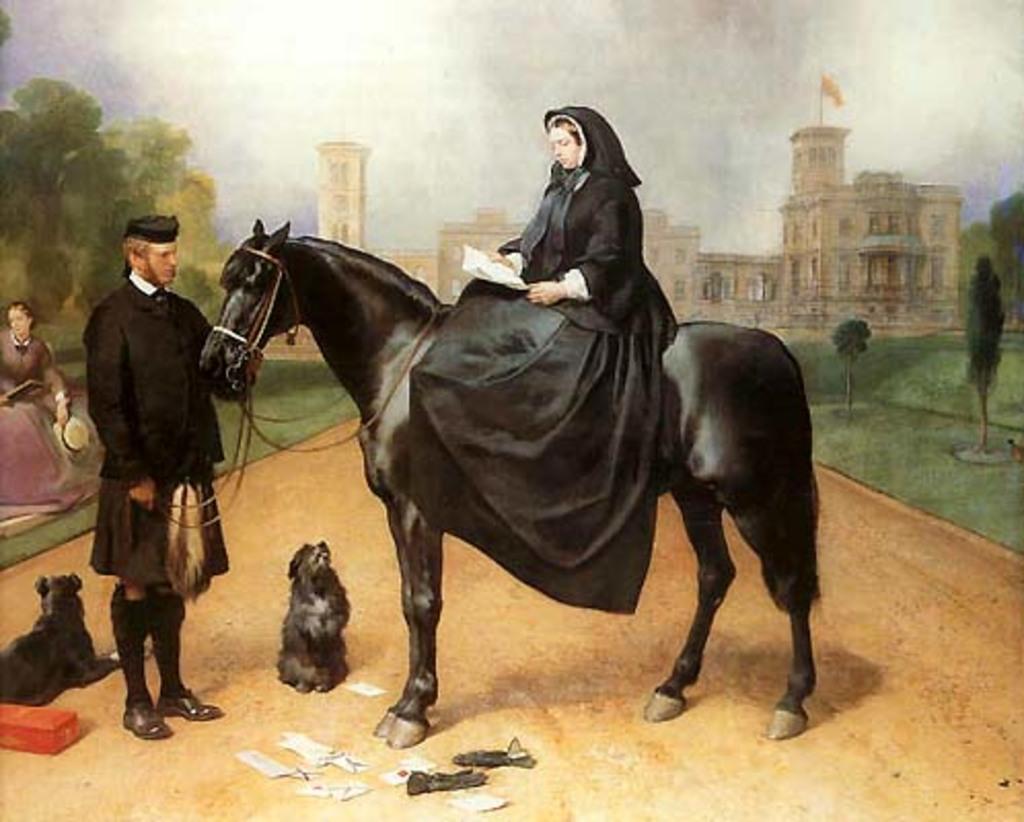Describe this image in one or two sentences. This is the painting were we can see a man is holding rope of a horse and on horse one lady is sitting by holding papers. Bottom of the image dogs, paper and one box is there. Background of the image trees, grass land and building is present. 